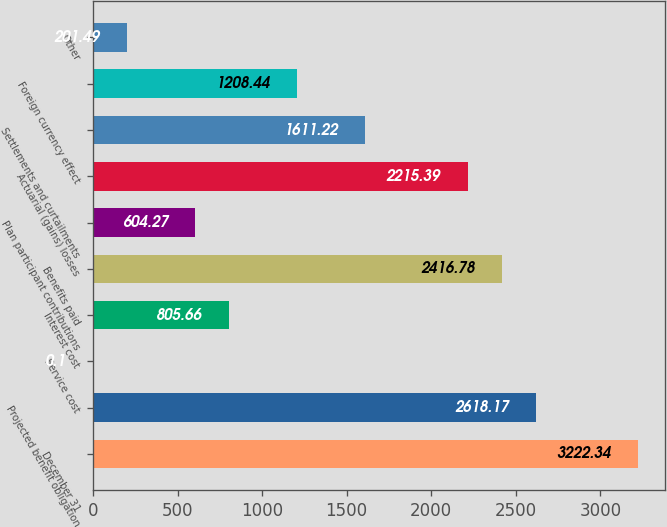Convert chart. <chart><loc_0><loc_0><loc_500><loc_500><bar_chart><fcel>December 31<fcel>Projected benefit obligation<fcel>Service cost<fcel>Interest cost<fcel>Benefits paid<fcel>Plan participant contributions<fcel>Actuarial (gains) losses<fcel>Settlements and curtailments<fcel>Foreign currency effect<fcel>Other<nl><fcel>3222.34<fcel>2618.17<fcel>0.1<fcel>805.66<fcel>2416.78<fcel>604.27<fcel>2215.39<fcel>1611.22<fcel>1208.44<fcel>201.49<nl></chart> 